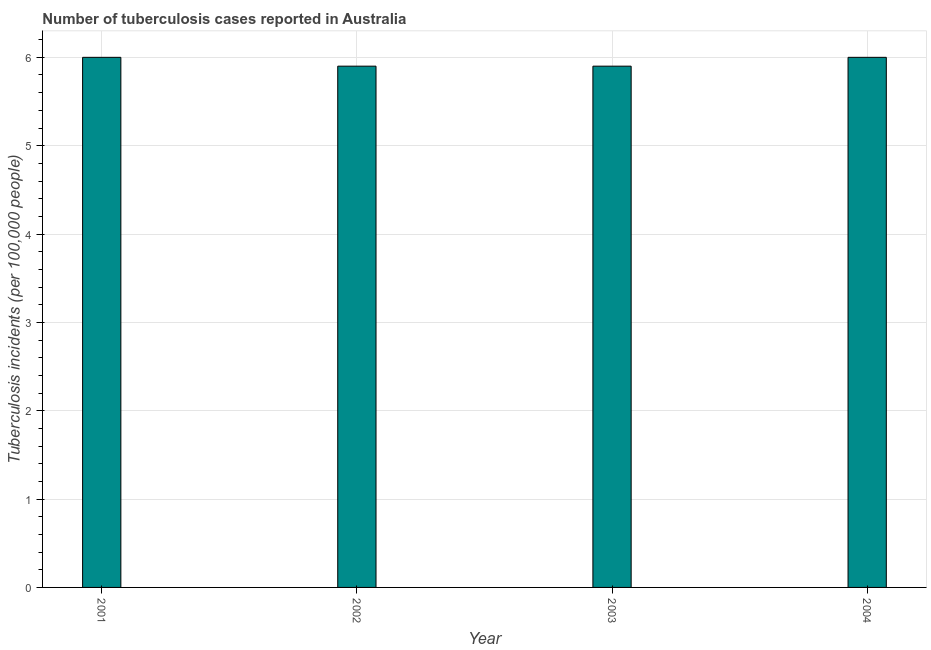What is the title of the graph?
Your answer should be very brief. Number of tuberculosis cases reported in Australia. What is the label or title of the Y-axis?
Provide a succinct answer. Tuberculosis incidents (per 100,0 people). What is the number of tuberculosis incidents in 2002?
Offer a terse response. 5.9. Across all years, what is the maximum number of tuberculosis incidents?
Keep it short and to the point. 6. In which year was the number of tuberculosis incidents minimum?
Offer a very short reply. 2002. What is the sum of the number of tuberculosis incidents?
Offer a terse response. 23.8. What is the average number of tuberculosis incidents per year?
Give a very brief answer. 5.95. What is the median number of tuberculosis incidents?
Provide a short and direct response. 5.95. What is the ratio of the number of tuberculosis incidents in 2003 to that in 2004?
Provide a short and direct response. 0.98. Is the difference between the number of tuberculosis incidents in 2002 and 2004 greater than the difference between any two years?
Provide a short and direct response. Yes. What is the difference between the highest and the lowest number of tuberculosis incidents?
Your response must be concise. 0.1. In how many years, is the number of tuberculosis incidents greater than the average number of tuberculosis incidents taken over all years?
Keep it short and to the point. 2. Are all the bars in the graph horizontal?
Keep it short and to the point. No. What is the difference between two consecutive major ticks on the Y-axis?
Make the answer very short. 1. What is the Tuberculosis incidents (per 100,000 people) of 2001?
Make the answer very short. 6. What is the Tuberculosis incidents (per 100,000 people) in 2003?
Give a very brief answer. 5.9. What is the Tuberculosis incidents (per 100,000 people) of 2004?
Provide a short and direct response. 6. What is the difference between the Tuberculosis incidents (per 100,000 people) in 2002 and 2003?
Offer a very short reply. 0. What is the difference between the Tuberculosis incidents (per 100,000 people) in 2003 and 2004?
Offer a terse response. -0.1. What is the ratio of the Tuberculosis incidents (per 100,000 people) in 2002 to that in 2004?
Make the answer very short. 0.98. 